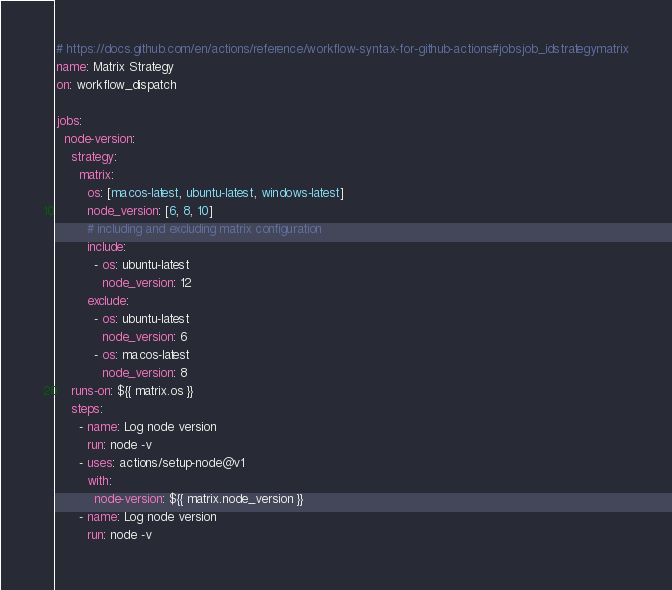Convert code to text. <code><loc_0><loc_0><loc_500><loc_500><_YAML_># https://docs.github.com/en/actions/reference/workflow-syntax-for-github-actions#jobsjob_idstrategymatrix
name: Matrix Strategy
on: workflow_dispatch 

jobs: 
  node-version:
    strategy: 
      matrix:
        os: [macos-latest, ubuntu-latest, windows-latest] 
        node_version: [6, 8, 10]
        # including and excluding matrix configuration
        include: 
          - os: ubuntu-latest
            node_version: 12
        exclude:
          - os: ubuntu-latest
            node_version: 6
          - os: macos-latest
            node_version: 8
    runs-on: ${{ matrix.os }}
    steps: 
      - name: Log node version 
        run: node -v
      - uses: actions/setup-node@v1
        with:
          node-version: ${{ matrix.node_version }}
      - name: Log node version 
        run: node -v
</code> 